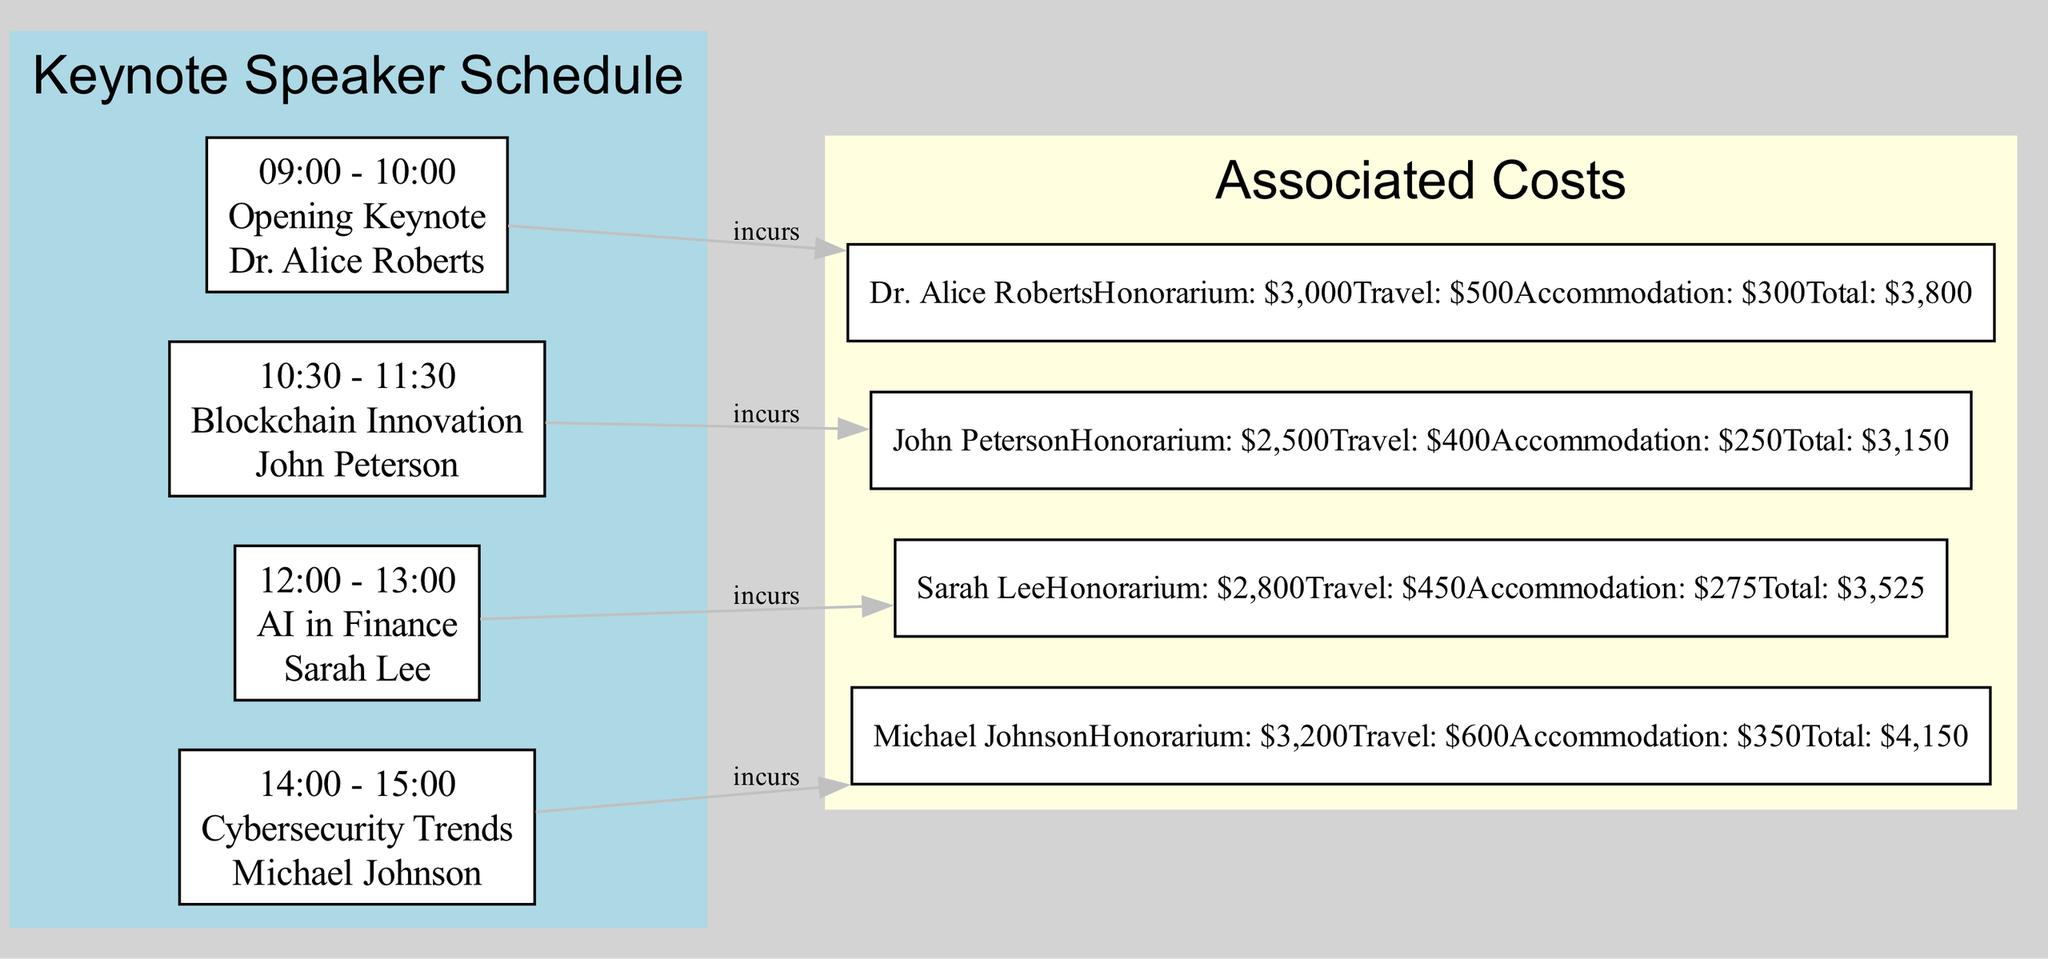What time does the opening keynote start? The diagram specifies that the opening keynote is scheduled for 09:00 - 10:00. This time frame indicates the start of the conference.
Answer: 09:00 Who is the speaker for the session on Cybersecurity Trends? The diagram shows that the speaker named for the session 14:00 - 15:00 is Michael Johnson, who discusses Cybersecurity Trends.
Answer: Michael Johnson What is the total cost for Sarah Lee? According to the breakdown provided in the diagram for Sarah Lee, her total cost is listed as $3,525.
Answer: $3,525 How many keynote speakers are scheduled for the conference? By counting the number of nodes representing speakers in the diagram, there are four keynote speakers listed, which indicates the total number of speakers.
Answer: 4 What is the relationship between the session on AI in Finance and associated costs? The diagram indicates that the session on AI in Finance involves costs, establishing a flow from the AI in Finance session to the costs incurred by the speaker, Sarah Lee.
Answer: Incurs What is the cumulative honorarium for all four speakers? To find the total honorarium, you add each speaker's honorarium: $3,000 (Alice Roberts) + $2,500 (John Peterson) + $2,800 (Sarah Lee) + $3,200 (Michael Johnson) = $11,500.
Answer: $11,500 Which speaker has the highest travel expense? By examining the travel expenses listed for each speaker in the costs section, Michael Johnson has the highest travel expense of $600.
Answer: Michael Johnson What is the time duration of each keynote session? Each session is scheduled for a one-hour duration, which can be illustrated from the time interval presented for each of the sessions in the diagram.
Answer: 1 hour What is the total accommodation cost for all speakers? The total accommodation cost is calculated by adding each speaker's accommodation costs: $300 (Alice) + $250 (John) + $275 (Sarah) + $350 (Michael) = $1,175.
Answer: $1,175 